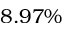Convert formula to latex. <formula><loc_0><loc_0><loc_500><loc_500>8 . 9 7 \%</formula> 